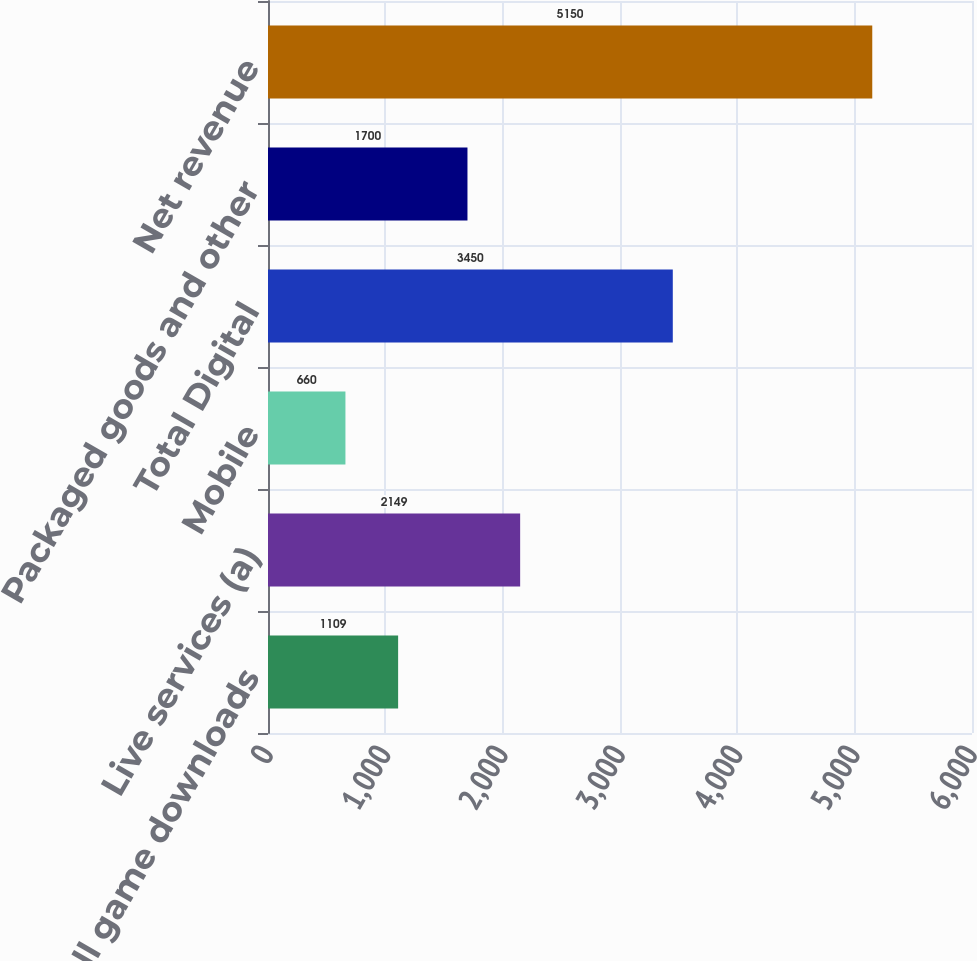Convert chart to OTSL. <chart><loc_0><loc_0><loc_500><loc_500><bar_chart><fcel>Full game downloads<fcel>Live services (a)<fcel>Mobile<fcel>Total Digital<fcel>Packaged goods and other<fcel>Net revenue<nl><fcel>1109<fcel>2149<fcel>660<fcel>3450<fcel>1700<fcel>5150<nl></chart> 